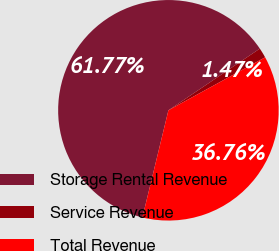Convert chart. <chart><loc_0><loc_0><loc_500><loc_500><pie_chart><fcel>Storage Rental Revenue<fcel>Service Revenue<fcel>Total Revenue<nl><fcel>61.76%<fcel>1.47%<fcel>36.76%<nl></chart> 